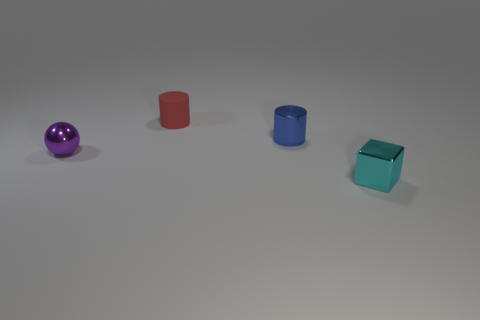Add 3 large cyan rubber blocks. How many objects exist? 7 Subtract all balls. How many objects are left? 3 Add 1 cyan metal things. How many cyan metal things are left? 2 Add 2 red matte balls. How many red matte balls exist? 2 Subtract 0 cyan cylinders. How many objects are left? 4 Subtract all tiny red cylinders. Subtract all tiny blocks. How many objects are left? 2 